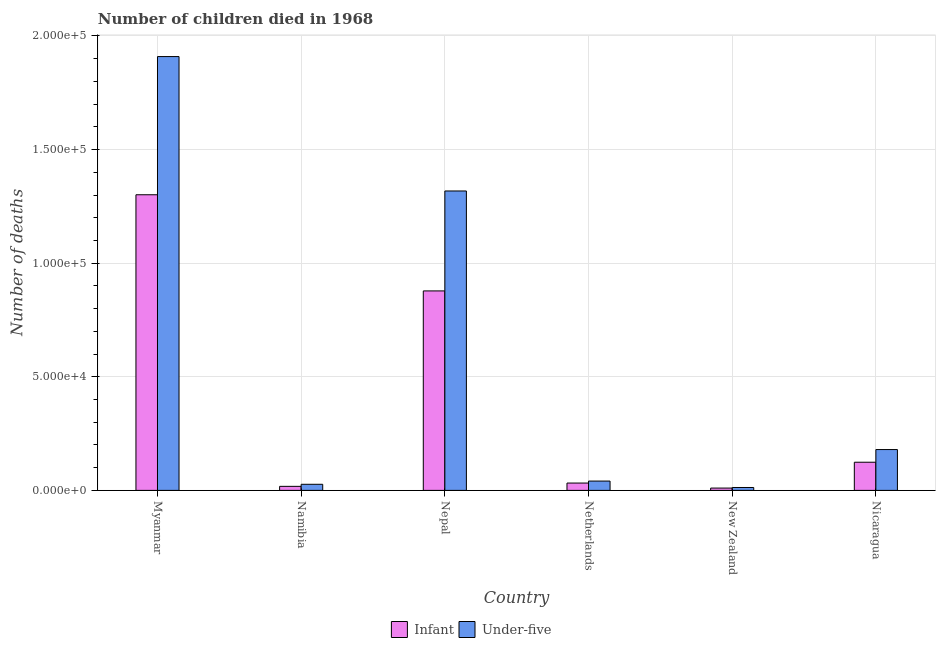How many different coloured bars are there?
Your answer should be compact. 2. How many groups of bars are there?
Keep it short and to the point. 6. Are the number of bars per tick equal to the number of legend labels?
Your answer should be very brief. Yes. Are the number of bars on each tick of the X-axis equal?
Provide a succinct answer. Yes. In how many cases, is the number of bars for a given country not equal to the number of legend labels?
Provide a succinct answer. 0. What is the number of under-five deaths in Namibia?
Your answer should be compact. 2686. Across all countries, what is the maximum number of under-five deaths?
Offer a terse response. 1.91e+05. Across all countries, what is the minimum number of infant deaths?
Provide a succinct answer. 1023. In which country was the number of under-five deaths maximum?
Give a very brief answer. Myanmar. In which country was the number of under-five deaths minimum?
Provide a succinct answer. New Zealand. What is the total number of infant deaths in the graph?
Give a very brief answer. 2.36e+05. What is the difference between the number of infant deaths in Myanmar and that in Nicaragua?
Offer a very short reply. 1.18e+05. What is the difference between the number of under-five deaths in Netherlands and the number of infant deaths in Myanmar?
Keep it short and to the point. -1.26e+05. What is the average number of under-five deaths per country?
Your answer should be very brief. 5.81e+04. What is the difference between the number of infant deaths and number of under-five deaths in New Zealand?
Keep it short and to the point. -251. In how many countries, is the number of under-five deaths greater than 120000 ?
Keep it short and to the point. 2. What is the ratio of the number of under-five deaths in Nepal to that in Nicaragua?
Your answer should be compact. 7.33. What is the difference between the highest and the second highest number of under-five deaths?
Provide a succinct answer. 5.92e+04. What is the difference between the highest and the lowest number of under-five deaths?
Make the answer very short. 1.90e+05. In how many countries, is the number of infant deaths greater than the average number of infant deaths taken over all countries?
Provide a succinct answer. 2. Is the sum of the number of under-five deaths in Netherlands and Nicaragua greater than the maximum number of infant deaths across all countries?
Your answer should be very brief. No. What does the 2nd bar from the left in New Zealand represents?
Your answer should be compact. Under-five. What does the 1st bar from the right in Myanmar represents?
Your answer should be very brief. Under-five. Does the graph contain grids?
Your answer should be compact. Yes. Where does the legend appear in the graph?
Make the answer very short. Bottom center. How many legend labels are there?
Make the answer very short. 2. How are the legend labels stacked?
Provide a short and direct response. Horizontal. What is the title of the graph?
Your answer should be compact. Number of children died in 1968. What is the label or title of the X-axis?
Your response must be concise. Country. What is the label or title of the Y-axis?
Your answer should be compact. Number of deaths. What is the Number of deaths in Infant in Myanmar?
Offer a terse response. 1.30e+05. What is the Number of deaths in Under-five in Myanmar?
Offer a terse response. 1.91e+05. What is the Number of deaths in Infant in Namibia?
Keep it short and to the point. 1779. What is the Number of deaths of Under-five in Namibia?
Ensure brevity in your answer.  2686. What is the Number of deaths of Infant in Nepal?
Your response must be concise. 8.78e+04. What is the Number of deaths in Under-five in Nepal?
Provide a succinct answer. 1.32e+05. What is the Number of deaths in Infant in Netherlands?
Provide a succinct answer. 3228. What is the Number of deaths in Under-five in Netherlands?
Make the answer very short. 4101. What is the Number of deaths in Infant in New Zealand?
Offer a very short reply. 1023. What is the Number of deaths of Under-five in New Zealand?
Give a very brief answer. 1274. What is the Number of deaths of Infant in Nicaragua?
Provide a succinct answer. 1.24e+04. What is the Number of deaths of Under-five in Nicaragua?
Your answer should be compact. 1.80e+04. Across all countries, what is the maximum Number of deaths of Infant?
Provide a succinct answer. 1.30e+05. Across all countries, what is the maximum Number of deaths of Under-five?
Offer a very short reply. 1.91e+05. Across all countries, what is the minimum Number of deaths in Infant?
Keep it short and to the point. 1023. Across all countries, what is the minimum Number of deaths in Under-five?
Ensure brevity in your answer.  1274. What is the total Number of deaths in Infant in the graph?
Your answer should be very brief. 2.36e+05. What is the total Number of deaths of Under-five in the graph?
Keep it short and to the point. 3.49e+05. What is the difference between the Number of deaths in Infant in Myanmar and that in Namibia?
Offer a terse response. 1.28e+05. What is the difference between the Number of deaths of Under-five in Myanmar and that in Namibia?
Your answer should be very brief. 1.88e+05. What is the difference between the Number of deaths of Infant in Myanmar and that in Nepal?
Your answer should be compact. 4.23e+04. What is the difference between the Number of deaths in Under-five in Myanmar and that in Nepal?
Provide a short and direct response. 5.92e+04. What is the difference between the Number of deaths in Infant in Myanmar and that in Netherlands?
Offer a terse response. 1.27e+05. What is the difference between the Number of deaths in Under-five in Myanmar and that in Netherlands?
Give a very brief answer. 1.87e+05. What is the difference between the Number of deaths in Infant in Myanmar and that in New Zealand?
Your response must be concise. 1.29e+05. What is the difference between the Number of deaths of Under-five in Myanmar and that in New Zealand?
Offer a very short reply. 1.90e+05. What is the difference between the Number of deaths of Infant in Myanmar and that in Nicaragua?
Keep it short and to the point. 1.18e+05. What is the difference between the Number of deaths of Under-five in Myanmar and that in Nicaragua?
Your answer should be compact. 1.73e+05. What is the difference between the Number of deaths in Infant in Namibia and that in Nepal?
Provide a succinct answer. -8.60e+04. What is the difference between the Number of deaths of Under-five in Namibia and that in Nepal?
Your answer should be very brief. -1.29e+05. What is the difference between the Number of deaths of Infant in Namibia and that in Netherlands?
Provide a short and direct response. -1449. What is the difference between the Number of deaths in Under-five in Namibia and that in Netherlands?
Make the answer very short. -1415. What is the difference between the Number of deaths of Infant in Namibia and that in New Zealand?
Offer a very short reply. 756. What is the difference between the Number of deaths of Under-five in Namibia and that in New Zealand?
Your answer should be compact. 1412. What is the difference between the Number of deaths in Infant in Namibia and that in Nicaragua?
Your answer should be very brief. -1.06e+04. What is the difference between the Number of deaths of Under-five in Namibia and that in Nicaragua?
Ensure brevity in your answer.  -1.53e+04. What is the difference between the Number of deaths in Infant in Nepal and that in Netherlands?
Make the answer very short. 8.46e+04. What is the difference between the Number of deaths of Under-five in Nepal and that in Netherlands?
Keep it short and to the point. 1.28e+05. What is the difference between the Number of deaths of Infant in Nepal and that in New Zealand?
Provide a succinct answer. 8.68e+04. What is the difference between the Number of deaths of Under-five in Nepal and that in New Zealand?
Provide a succinct answer. 1.30e+05. What is the difference between the Number of deaths in Infant in Nepal and that in Nicaragua?
Your answer should be very brief. 7.54e+04. What is the difference between the Number of deaths in Under-five in Nepal and that in Nicaragua?
Your answer should be very brief. 1.14e+05. What is the difference between the Number of deaths in Infant in Netherlands and that in New Zealand?
Provide a succinct answer. 2205. What is the difference between the Number of deaths in Under-five in Netherlands and that in New Zealand?
Your answer should be very brief. 2827. What is the difference between the Number of deaths of Infant in Netherlands and that in Nicaragua?
Provide a succinct answer. -9165. What is the difference between the Number of deaths in Under-five in Netherlands and that in Nicaragua?
Your answer should be very brief. -1.39e+04. What is the difference between the Number of deaths of Infant in New Zealand and that in Nicaragua?
Provide a short and direct response. -1.14e+04. What is the difference between the Number of deaths of Under-five in New Zealand and that in Nicaragua?
Offer a terse response. -1.67e+04. What is the difference between the Number of deaths of Infant in Myanmar and the Number of deaths of Under-five in Namibia?
Your answer should be compact. 1.27e+05. What is the difference between the Number of deaths in Infant in Myanmar and the Number of deaths in Under-five in Nepal?
Make the answer very short. -1661. What is the difference between the Number of deaths in Infant in Myanmar and the Number of deaths in Under-five in Netherlands?
Your answer should be compact. 1.26e+05. What is the difference between the Number of deaths in Infant in Myanmar and the Number of deaths in Under-five in New Zealand?
Keep it short and to the point. 1.29e+05. What is the difference between the Number of deaths in Infant in Myanmar and the Number of deaths in Under-five in Nicaragua?
Provide a short and direct response. 1.12e+05. What is the difference between the Number of deaths in Infant in Namibia and the Number of deaths in Under-five in Nepal?
Provide a succinct answer. -1.30e+05. What is the difference between the Number of deaths in Infant in Namibia and the Number of deaths in Under-five in Netherlands?
Make the answer very short. -2322. What is the difference between the Number of deaths of Infant in Namibia and the Number of deaths of Under-five in New Zealand?
Offer a very short reply. 505. What is the difference between the Number of deaths in Infant in Namibia and the Number of deaths in Under-five in Nicaragua?
Your answer should be compact. -1.62e+04. What is the difference between the Number of deaths in Infant in Nepal and the Number of deaths in Under-five in Netherlands?
Ensure brevity in your answer.  8.37e+04. What is the difference between the Number of deaths in Infant in Nepal and the Number of deaths in Under-five in New Zealand?
Keep it short and to the point. 8.65e+04. What is the difference between the Number of deaths of Infant in Nepal and the Number of deaths of Under-five in Nicaragua?
Keep it short and to the point. 6.98e+04. What is the difference between the Number of deaths in Infant in Netherlands and the Number of deaths in Under-five in New Zealand?
Offer a very short reply. 1954. What is the difference between the Number of deaths of Infant in Netherlands and the Number of deaths of Under-five in Nicaragua?
Ensure brevity in your answer.  -1.47e+04. What is the difference between the Number of deaths of Infant in New Zealand and the Number of deaths of Under-five in Nicaragua?
Provide a short and direct response. -1.69e+04. What is the average Number of deaths of Infant per country?
Your response must be concise. 3.94e+04. What is the average Number of deaths in Under-five per country?
Your response must be concise. 5.81e+04. What is the difference between the Number of deaths in Infant and Number of deaths in Under-five in Myanmar?
Provide a short and direct response. -6.08e+04. What is the difference between the Number of deaths of Infant and Number of deaths of Under-five in Namibia?
Keep it short and to the point. -907. What is the difference between the Number of deaths in Infant and Number of deaths in Under-five in Nepal?
Provide a short and direct response. -4.40e+04. What is the difference between the Number of deaths of Infant and Number of deaths of Under-five in Netherlands?
Your answer should be very brief. -873. What is the difference between the Number of deaths of Infant and Number of deaths of Under-five in New Zealand?
Offer a very short reply. -251. What is the difference between the Number of deaths of Infant and Number of deaths of Under-five in Nicaragua?
Provide a succinct answer. -5579. What is the ratio of the Number of deaths in Infant in Myanmar to that in Namibia?
Provide a succinct answer. 73.14. What is the ratio of the Number of deaths of Under-five in Myanmar to that in Namibia?
Keep it short and to the point. 71.08. What is the ratio of the Number of deaths of Infant in Myanmar to that in Nepal?
Ensure brevity in your answer.  1.48. What is the ratio of the Number of deaths in Under-five in Myanmar to that in Nepal?
Provide a short and direct response. 1.45. What is the ratio of the Number of deaths in Infant in Myanmar to that in Netherlands?
Give a very brief answer. 40.31. What is the ratio of the Number of deaths in Under-five in Myanmar to that in Netherlands?
Make the answer very short. 46.56. What is the ratio of the Number of deaths in Infant in Myanmar to that in New Zealand?
Your answer should be compact. 127.19. What is the ratio of the Number of deaths of Under-five in Myanmar to that in New Zealand?
Keep it short and to the point. 149.86. What is the ratio of the Number of deaths of Infant in Myanmar to that in Nicaragua?
Your answer should be compact. 10.5. What is the ratio of the Number of deaths in Under-five in Myanmar to that in Nicaragua?
Your answer should be very brief. 10.62. What is the ratio of the Number of deaths of Infant in Namibia to that in Nepal?
Make the answer very short. 0.02. What is the ratio of the Number of deaths of Under-five in Namibia to that in Nepal?
Ensure brevity in your answer.  0.02. What is the ratio of the Number of deaths in Infant in Namibia to that in Netherlands?
Ensure brevity in your answer.  0.55. What is the ratio of the Number of deaths of Under-five in Namibia to that in Netherlands?
Your answer should be compact. 0.66. What is the ratio of the Number of deaths in Infant in Namibia to that in New Zealand?
Your response must be concise. 1.74. What is the ratio of the Number of deaths in Under-five in Namibia to that in New Zealand?
Your response must be concise. 2.11. What is the ratio of the Number of deaths in Infant in Namibia to that in Nicaragua?
Provide a succinct answer. 0.14. What is the ratio of the Number of deaths of Under-five in Namibia to that in Nicaragua?
Your response must be concise. 0.15. What is the ratio of the Number of deaths of Infant in Nepal to that in Netherlands?
Your answer should be compact. 27.2. What is the ratio of the Number of deaths in Under-five in Nepal to that in Netherlands?
Provide a short and direct response. 32.13. What is the ratio of the Number of deaths in Infant in Nepal to that in New Zealand?
Provide a short and direct response. 85.81. What is the ratio of the Number of deaths in Under-five in Nepal to that in New Zealand?
Give a very brief answer. 103.43. What is the ratio of the Number of deaths in Infant in Nepal to that in Nicaragua?
Your answer should be compact. 7.08. What is the ratio of the Number of deaths of Under-five in Nepal to that in Nicaragua?
Offer a very short reply. 7.33. What is the ratio of the Number of deaths in Infant in Netherlands to that in New Zealand?
Make the answer very short. 3.16. What is the ratio of the Number of deaths of Under-five in Netherlands to that in New Zealand?
Offer a terse response. 3.22. What is the ratio of the Number of deaths in Infant in Netherlands to that in Nicaragua?
Offer a terse response. 0.26. What is the ratio of the Number of deaths in Under-five in Netherlands to that in Nicaragua?
Give a very brief answer. 0.23. What is the ratio of the Number of deaths of Infant in New Zealand to that in Nicaragua?
Offer a terse response. 0.08. What is the ratio of the Number of deaths of Under-five in New Zealand to that in Nicaragua?
Your response must be concise. 0.07. What is the difference between the highest and the second highest Number of deaths of Infant?
Your answer should be very brief. 4.23e+04. What is the difference between the highest and the second highest Number of deaths in Under-five?
Offer a very short reply. 5.92e+04. What is the difference between the highest and the lowest Number of deaths of Infant?
Offer a terse response. 1.29e+05. What is the difference between the highest and the lowest Number of deaths of Under-five?
Ensure brevity in your answer.  1.90e+05. 